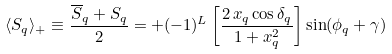<formula> <loc_0><loc_0><loc_500><loc_500>\langle S _ { q } \rangle _ { + } \equiv \frac { \overline { S } _ { q } + S _ { q } } { 2 } = + ( - 1 ) ^ { L } \left [ \frac { 2 \, x _ { q } \cos \delta _ { q } } { 1 + x _ { q } ^ { 2 } } \right ] \sin ( \phi _ { q } + \gamma )</formula> 